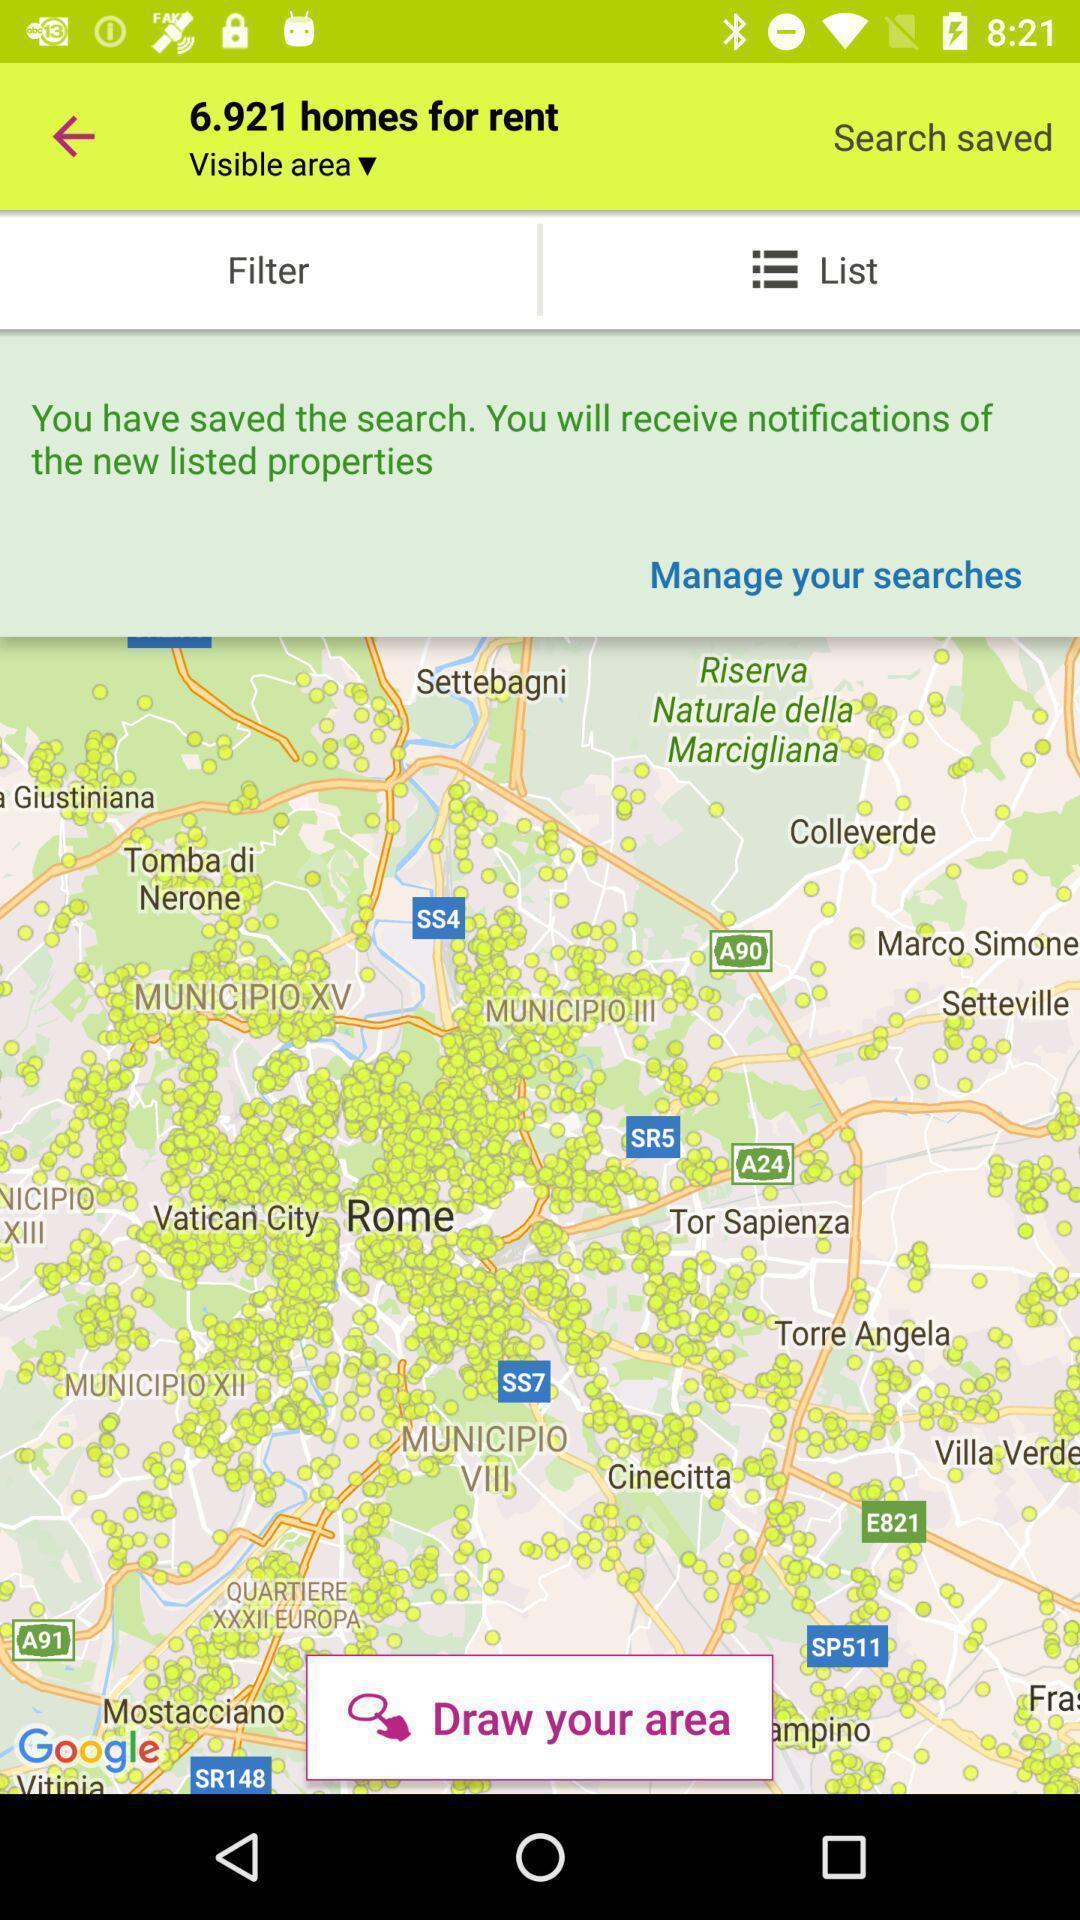Describe the visual elements of this screenshot. Screen shows home rent view options. 